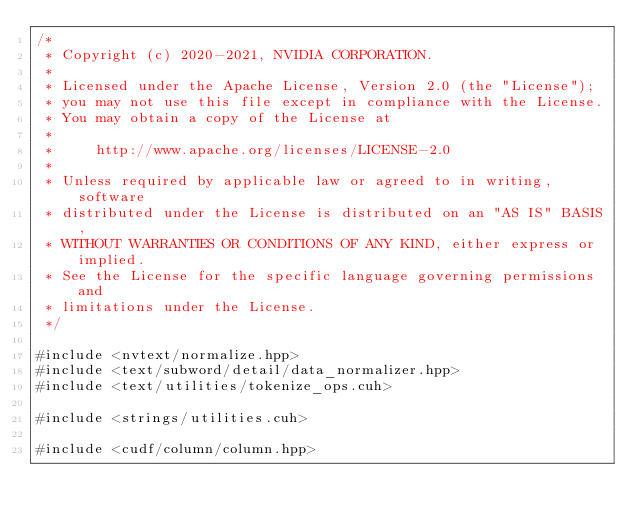Convert code to text. <code><loc_0><loc_0><loc_500><loc_500><_Cuda_>/*
 * Copyright (c) 2020-2021, NVIDIA CORPORATION.
 *
 * Licensed under the Apache License, Version 2.0 (the "License");
 * you may not use this file except in compliance with the License.
 * You may obtain a copy of the License at
 *
 *     http://www.apache.org/licenses/LICENSE-2.0
 *
 * Unless required by applicable law or agreed to in writing, software
 * distributed under the License is distributed on an "AS IS" BASIS,
 * WITHOUT WARRANTIES OR CONDITIONS OF ANY KIND, either express or implied.
 * See the License for the specific language governing permissions and
 * limitations under the License.
 */

#include <nvtext/normalize.hpp>
#include <text/subword/detail/data_normalizer.hpp>
#include <text/utilities/tokenize_ops.cuh>

#include <strings/utilities.cuh>

#include <cudf/column/column.hpp></code> 